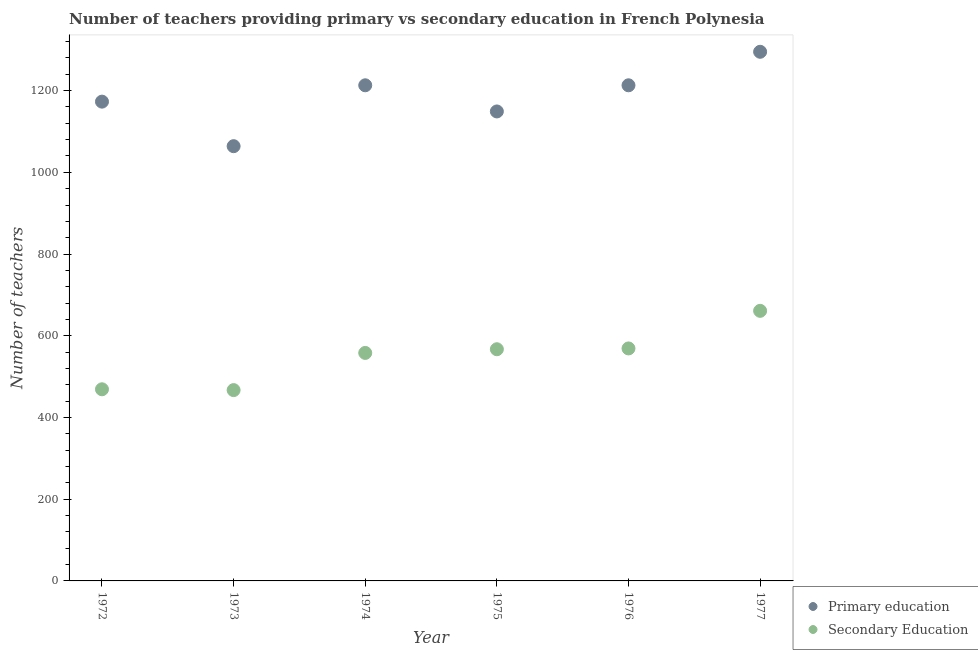Is the number of dotlines equal to the number of legend labels?
Provide a succinct answer. Yes. What is the number of secondary teachers in 1972?
Your answer should be compact. 469. Across all years, what is the maximum number of primary teachers?
Give a very brief answer. 1295. Across all years, what is the minimum number of primary teachers?
Give a very brief answer. 1064. In which year was the number of secondary teachers maximum?
Offer a very short reply. 1977. What is the total number of primary teachers in the graph?
Give a very brief answer. 7107. What is the difference between the number of secondary teachers in 1973 and that in 1977?
Make the answer very short. -194. What is the difference between the number of secondary teachers in 1974 and the number of primary teachers in 1977?
Your answer should be very brief. -737. What is the average number of primary teachers per year?
Ensure brevity in your answer.  1184.5. In the year 1975, what is the difference between the number of secondary teachers and number of primary teachers?
Your answer should be very brief. -582. In how many years, is the number of secondary teachers greater than 40?
Offer a terse response. 6. What is the ratio of the number of secondary teachers in 1974 to that in 1975?
Keep it short and to the point. 0.98. Is the number of secondary teachers in 1972 less than that in 1976?
Keep it short and to the point. Yes. What is the difference between the highest and the lowest number of primary teachers?
Your response must be concise. 231. Is the number of primary teachers strictly greater than the number of secondary teachers over the years?
Offer a terse response. Yes. Is the number of secondary teachers strictly less than the number of primary teachers over the years?
Provide a succinct answer. Yes. How many years are there in the graph?
Give a very brief answer. 6. What is the title of the graph?
Keep it short and to the point. Number of teachers providing primary vs secondary education in French Polynesia. Does "Grants" appear as one of the legend labels in the graph?
Offer a very short reply. No. What is the label or title of the X-axis?
Offer a terse response. Year. What is the label or title of the Y-axis?
Keep it short and to the point. Number of teachers. What is the Number of teachers in Primary education in 1972?
Keep it short and to the point. 1173. What is the Number of teachers of Secondary Education in 1972?
Give a very brief answer. 469. What is the Number of teachers in Primary education in 1973?
Your answer should be compact. 1064. What is the Number of teachers of Secondary Education in 1973?
Your answer should be very brief. 467. What is the Number of teachers of Primary education in 1974?
Your answer should be very brief. 1213. What is the Number of teachers of Secondary Education in 1974?
Your response must be concise. 558. What is the Number of teachers of Primary education in 1975?
Your response must be concise. 1149. What is the Number of teachers in Secondary Education in 1975?
Provide a short and direct response. 567. What is the Number of teachers of Primary education in 1976?
Ensure brevity in your answer.  1213. What is the Number of teachers in Secondary Education in 1976?
Your answer should be very brief. 569. What is the Number of teachers in Primary education in 1977?
Provide a succinct answer. 1295. What is the Number of teachers of Secondary Education in 1977?
Provide a succinct answer. 661. Across all years, what is the maximum Number of teachers in Primary education?
Make the answer very short. 1295. Across all years, what is the maximum Number of teachers of Secondary Education?
Provide a succinct answer. 661. Across all years, what is the minimum Number of teachers of Primary education?
Provide a short and direct response. 1064. Across all years, what is the minimum Number of teachers in Secondary Education?
Provide a succinct answer. 467. What is the total Number of teachers of Primary education in the graph?
Provide a succinct answer. 7107. What is the total Number of teachers of Secondary Education in the graph?
Offer a very short reply. 3291. What is the difference between the Number of teachers in Primary education in 1972 and that in 1973?
Provide a succinct answer. 109. What is the difference between the Number of teachers in Secondary Education in 1972 and that in 1973?
Provide a short and direct response. 2. What is the difference between the Number of teachers of Primary education in 1972 and that in 1974?
Give a very brief answer. -40. What is the difference between the Number of teachers of Secondary Education in 1972 and that in 1974?
Make the answer very short. -89. What is the difference between the Number of teachers of Primary education in 1972 and that in 1975?
Give a very brief answer. 24. What is the difference between the Number of teachers of Secondary Education in 1972 and that in 1975?
Make the answer very short. -98. What is the difference between the Number of teachers of Primary education in 1972 and that in 1976?
Ensure brevity in your answer.  -40. What is the difference between the Number of teachers in Secondary Education in 1972 and that in 1976?
Ensure brevity in your answer.  -100. What is the difference between the Number of teachers of Primary education in 1972 and that in 1977?
Your answer should be very brief. -122. What is the difference between the Number of teachers in Secondary Education in 1972 and that in 1977?
Make the answer very short. -192. What is the difference between the Number of teachers of Primary education in 1973 and that in 1974?
Your answer should be compact. -149. What is the difference between the Number of teachers in Secondary Education in 1973 and that in 1974?
Offer a very short reply. -91. What is the difference between the Number of teachers in Primary education in 1973 and that in 1975?
Provide a short and direct response. -85. What is the difference between the Number of teachers in Secondary Education in 1973 and that in 1975?
Keep it short and to the point. -100. What is the difference between the Number of teachers in Primary education in 1973 and that in 1976?
Make the answer very short. -149. What is the difference between the Number of teachers in Secondary Education in 1973 and that in 1976?
Ensure brevity in your answer.  -102. What is the difference between the Number of teachers of Primary education in 1973 and that in 1977?
Provide a succinct answer. -231. What is the difference between the Number of teachers in Secondary Education in 1973 and that in 1977?
Give a very brief answer. -194. What is the difference between the Number of teachers in Primary education in 1974 and that in 1975?
Make the answer very short. 64. What is the difference between the Number of teachers of Primary education in 1974 and that in 1976?
Give a very brief answer. 0. What is the difference between the Number of teachers of Secondary Education in 1974 and that in 1976?
Your answer should be compact. -11. What is the difference between the Number of teachers in Primary education in 1974 and that in 1977?
Ensure brevity in your answer.  -82. What is the difference between the Number of teachers of Secondary Education in 1974 and that in 1977?
Provide a short and direct response. -103. What is the difference between the Number of teachers in Primary education in 1975 and that in 1976?
Give a very brief answer. -64. What is the difference between the Number of teachers in Primary education in 1975 and that in 1977?
Your answer should be compact. -146. What is the difference between the Number of teachers of Secondary Education in 1975 and that in 1977?
Your answer should be very brief. -94. What is the difference between the Number of teachers of Primary education in 1976 and that in 1977?
Your response must be concise. -82. What is the difference between the Number of teachers in Secondary Education in 1976 and that in 1977?
Your answer should be compact. -92. What is the difference between the Number of teachers in Primary education in 1972 and the Number of teachers in Secondary Education in 1973?
Give a very brief answer. 706. What is the difference between the Number of teachers in Primary education in 1972 and the Number of teachers in Secondary Education in 1974?
Make the answer very short. 615. What is the difference between the Number of teachers in Primary education in 1972 and the Number of teachers in Secondary Education in 1975?
Make the answer very short. 606. What is the difference between the Number of teachers of Primary education in 1972 and the Number of teachers of Secondary Education in 1976?
Your response must be concise. 604. What is the difference between the Number of teachers of Primary education in 1972 and the Number of teachers of Secondary Education in 1977?
Your response must be concise. 512. What is the difference between the Number of teachers of Primary education in 1973 and the Number of teachers of Secondary Education in 1974?
Your answer should be compact. 506. What is the difference between the Number of teachers in Primary education in 1973 and the Number of teachers in Secondary Education in 1975?
Your response must be concise. 497. What is the difference between the Number of teachers of Primary education in 1973 and the Number of teachers of Secondary Education in 1976?
Offer a very short reply. 495. What is the difference between the Number of teachers of Primary education in 1973 and the Number of teachers of Secondary Education in 1977?
Provide a short and direct response. 403. What is the difference between the Number of teachers of Primary education in 1974 and the Number of teachers of Secondary Education in 1975?
Make the answer very short. 646. What is the difference between the Number of teachers in Primary education in 1974 and the Number of teachers in Secondary Education in 1976?
Make the answer very short. 644. What is the difference between the Number of teachers of Primary education in 1974 and the Number of teachers of Secondary Education in 1977?
Your answer should be very brief. 552. What is the difference between the Number of teachers in Primary education in 1975 and the Number of teachers in Secondary Education in 1976?
Your answer should be compact. 580. What is the difference between the Number of teachers of Primary education in 1975 and the Number of teachers of Secondary Education in 1977?
Ensure brevity in your answer.  488. What is the difference between the Number of teachers of Primary education in 1976 and the Number of teachers of Secondary Education in 1977?
Keep it short and to the point. 552. What is the average Number of teachers in Primary education per year?
Provide a short and direct response. 1184.5. What is the average Number of teachers in Secondary Education per year?
Offer a terse response. 548.5. In the year 1972, what is the difference between the Number of teachers of Primary education and Number of teachers of Secondary Education?
Provide a short and direct response. 704. In the year 1973, what is the difference between the Number of teachers in Primary education and Number of teachers in Secondary Education?
Offer a terse response. 597. In the year 1974, what is the difference between the Number of teachers in Primary education and Number of teachers in Secondary Education?
Your response must be concise. 655. In the year 1975, what is the difference between the Number of teachers of Primary education and Number of teachers of Secondary Education?
Offer a very short reply. 582. In the year 1976, what is the difference between the Number of teachers of Primary education and Number of teachers of Secondary Education?
Offer a very short reply. 644. In the year 1977, what is the difference between the Number of teachers of Primary education and Number of teachers of Secondary Education?
Offer a very short reply. 634. What is the ratio of the Number of teachers in Primary education in 1972 to that in 1973?
Keep it short and to the point. 1.1. What is the ratio of the Number of teachers in Primary education in 1972 to that in 1974?
Give a very brief answer. 0.97. What is the ratio of the Number of teachers of Secondary Education in 1972 to that in 1974?
Provide a short and direct response. 0.84. What is the ratio of the Number of teachers in Primary education in 1972 to that in 1975?
Your answer should be compact. 1.02. What is the ratio of the Number of teachers in Secondary Education in 1972 to that in 1975?
Your answer should be very brief. 0.83. What is the ratio of the Number of teachers in Primary education in 1972 to that in 1976?
Offer a very short reply. 0.97. What is the ratio of the Number of teachers in Secondary Education in 1972 to that in 1976?
Make the answer very short. 0.82. What is the ratio of the Number of teachers of Primary education in 1972 to that in 1977?
Offer a very short reply. 0.91. What is the ratio of the Number of teachers in Secondary Education in 1972 to that in 1977?
Your response must be concise. 0.71. What is the ratio of the Number of teachers of Primary education in 1973 to that in 1974?
Give a very brief answer. 0.88. What is the ratio of the Number of teachers of Secondary Education in 1973 to that in 1974?
Your response must be concise. 0.84. What is the ratio of the Number of teachers in Primary education in 1973 to that in 1975?
Provide a short and direct response. 0.93. What is the ratio of the Number of teachers of Secondary Education in 1973 to that in 1975?
Give a very brief answer. 0.82. What is the ratio of the Number of teachers of Primary education in 1973 to that in 1976?
Offer a terse response. 0.88. What is the ratio of the Number of teachers in Secondary Education in 1973 to that in 1976?
Offer a very short reply. 0.82. What is the ratio of the Number of teachers of Primary education in 1973 to that in 1977?
Keep it short and to the point. 0.82. What is the ratio of the Number of teachers of Secondary Education in 1973 to that in 1977?
Your answer should be very brief. 0.71. What is the ratio of the Number of teachers in Primary education in 1974 to that in 1975?
Give a very brief answer. 1.06. What is the ratio of the Number of teachers in Secondary Education in 1974 to that in 1975?
Ensure brevity in your answer.  0.98. What is the ratio of the Number of teachers of Primary education in 1974 to that in 1976?
Your answer should be very brief. 1. What is the ratio of the Number of teachers in Secondary Education in 1974 to that in 1976?
Provide a short and direct response. 0.98. What is the ratio of the Number of teachers of Primary education in 1974 to that in 1977?
Your response must be concise. 0.94. What is the ratio of the Number of teachers in Secondary Education in 1974 to that in 1977?
Keep it short and to the point. 0.84. What is the ratio of the Number of teachers of Primary education in 1975 to that in 1976?
Ensure brevity in your answer.  0.95. What is the ratio of the Number of teachers of Primary education in 1975 to that in 1977?
Provide a short and direct response. 0.89. What is the ratio of the Number of teachers in Secondary Education in 1975 to that in 1977?
Keep it short and to the point. 0.86. What is the ratio of the Number of teachers in Primary education in 1976 to that in 1977?
Make the answer very short. 0.94. What is the ratio of the Number of teachers in Secondary Education in 1976 to that in 1977?
Ensure brevity in your answer.  0.86. What is the difference between the highest and the second highest Number of teachers in Secondary Education?
Your answer should be compact. 92. What is the difference between the highest and the lowest Number of teachers in Primary education?
Your answer should be very brief. 231. What is the difference between the highest and the lowest Number of teachers of Secondary Education?
Offer a terse response. 194. 